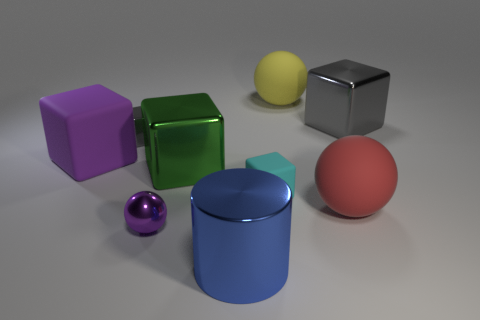Can you tell me what colors are present in the objects displayed in the image? Certainly! The objects in the image feature a variety of vibrant colors: there's a purple cube, a green cube, a yellow sphere, a reflective silver cube, a blue cylinder, a smaller purple sphere, and a red sphere. 